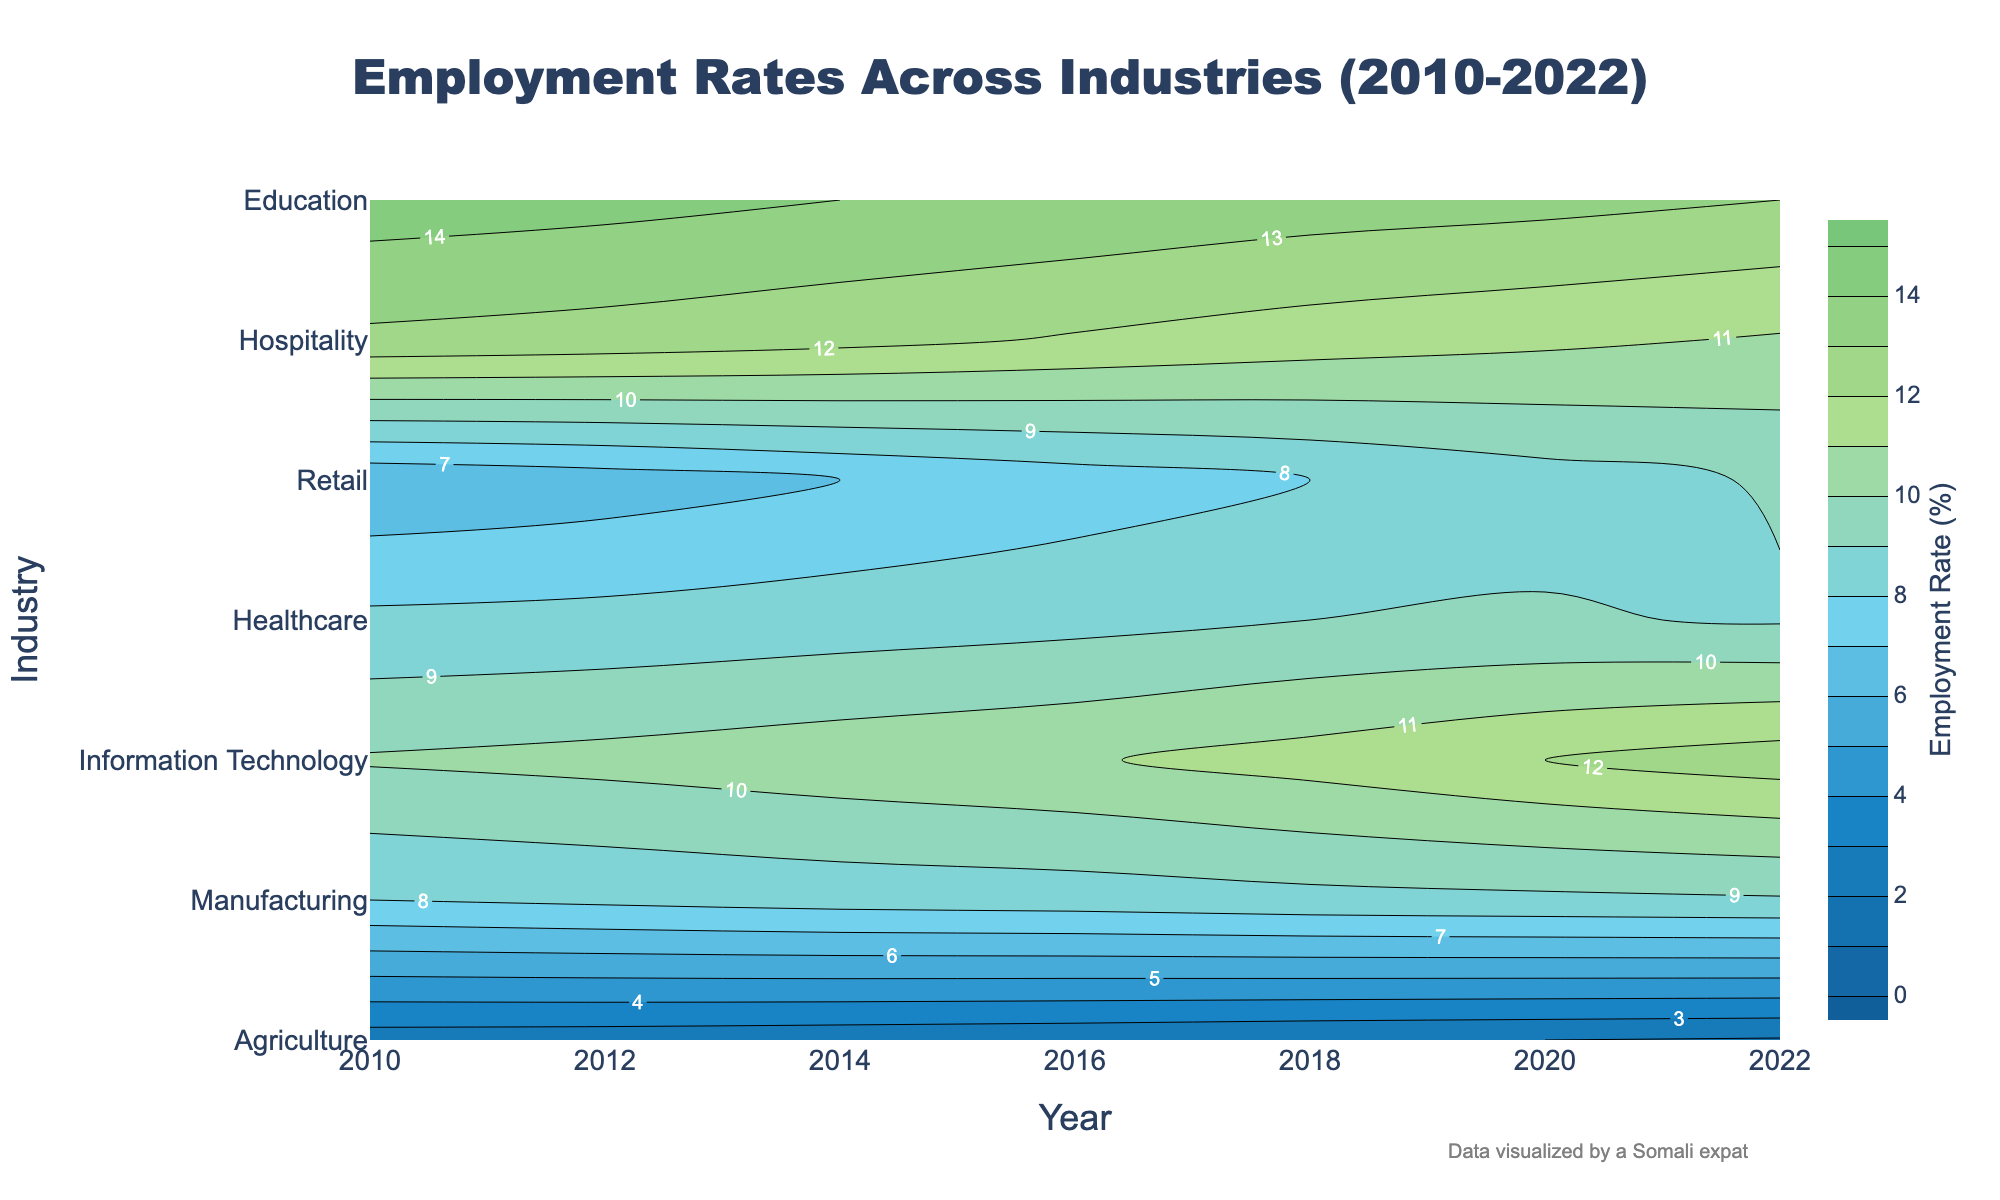What's the employment rate in Agriculture in 2022? To find the employment rate in Agriculture in 2022, look at the contour plot where the x-axis is 2022 and the y-axis is Agriculture. Locate the corresponding value.
Answer: 1.9% Which industry had the highest employment rate in 2010? To determine the industry with the highest employment rate in 2010, compare the highest value along the 2010 mark on the x-axis across all industries on the y-axis.
Answer: Retail How did the employment rate in Information Technology change from 2010 to 2022? Observe the contour line corresponding to Information Technology and note the employment rate values for 2010 and 2022. Then calculate the difference between these values.
Answer: Increased by 2.9% In which year did Manufacturing see the steepest decline in employment rate? Examine the contour lines for Manufacturing and observe the changes in the rate between consecutive years. Identify the pair of years with the most significant change.
Answer: 2014–2016 What's the average employment rate in Healthcare between 2010 and 2022? Find the employment rates for Healthcare for each year between 2010 and 2022, sum them up, and divide by the number of years to get the average.
Answer: 11.1% Which two industries had nearly equal employment rates in 2020? Look at the contour plot values for different industries in 2020 and identify the two closest employment rates.
Answer: Hospitality and Education Compare the trend of employment rates in Retail and Hospitality from 2010 to 2022. Track the contour lines for Retail and Hospitality from 2010 to 2022 and describe their changes over time, noting any similarities or differences in trend.
Answer: Both increased initially but Hospitality peaked earlier What is the range of employment rates for the Education industry from 2010 to 2022? Identify the minimum and maximum employment rates for the Education industry from the contour plot between 2010 and 2022. Calculate their difference.
Answer: 0.9% Which industry showed the least fluctuation in employment rates over the years? Compare the steepness and variation in the contour lines for each industry. Identify the industry with the least changes in its employment rate values.
Answer: Education What proportion of the total employment rate in 2022 does the Agriculture industry contribute? Identify the total employment rate for 2022 by summing up the rates of all industries in 2022. Then, divide the employment rate of Agriculture by this total and multiply by 100 to find the proportion.
Answer: (1.9 / 65.3) * 100 = 2.91% 